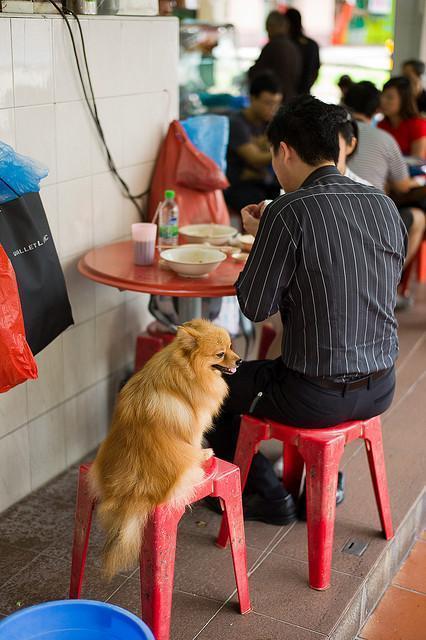How many people are visible?
Give a very brief answer. 5. 